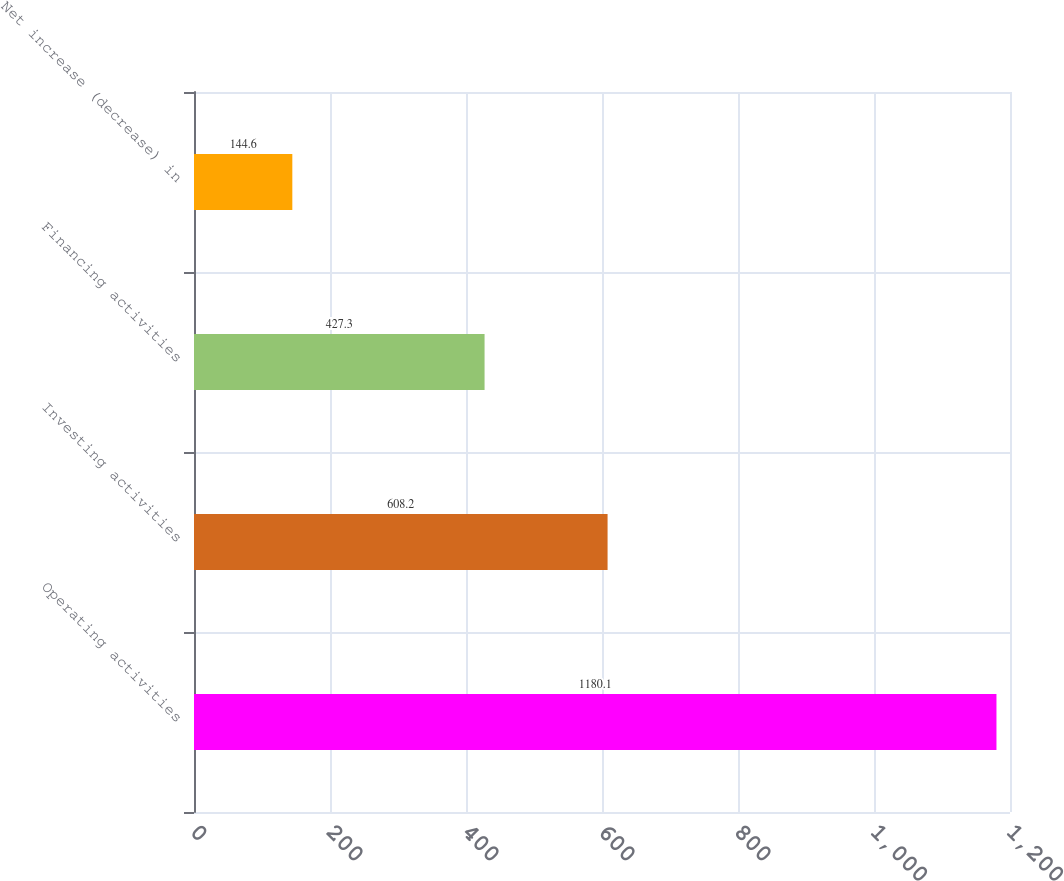Convert chart. <chart><loc_0><loc_0><loc_500><loc_500><bar_chart><fcel>Operating activities<fcel>Investing activities<fcel>Financing activities<fcel>Net increase (decrease) in<nl><fcel>1180.1<fcel>608.2<fcel>427.3<fcel>144.6<nl></chart> 